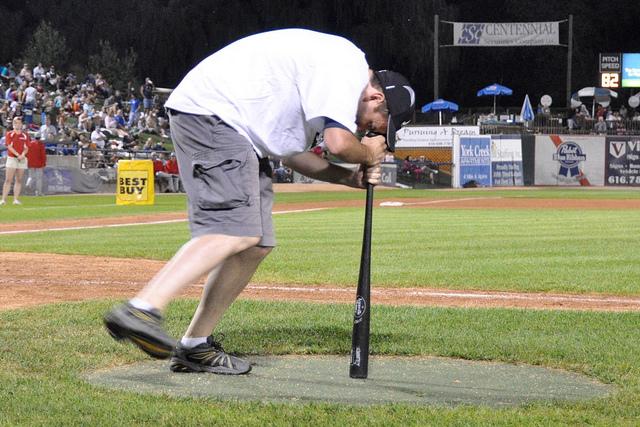How is the man standing?
Concise answer only. Leaning on bat. What does the yellow sign say?
Quick response, please. Best buy. Is this Yankee Stadium?
Quick response, please. No. What is the man spinning around?
Be succinct. Bat. Why is the player diving back to first base?
Keep it brief. No. 